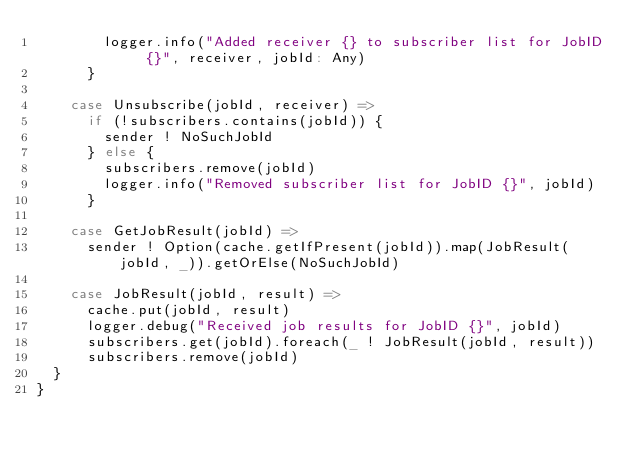Convert code to text. <code><loc_0><loc_0><loc_500><loc_500><_Scala_>        logger.info("Added receiver {} to subscriber list for JobID {}", receiver, jobId: Any)
      }

    case Unsubscribe(jobId, receiver) =>
      if (!subscribers.contains(jobId)) {
        sender ! NoSuchJobId
      } else {
        subscribers.remove(jobId)
        logger.info("Removed subscriber list for JobID {}", jobId)
      }

    case GetJobResult(jobId) =>
      sender ! Option(cache.getIfPresent(jobId)).map(JobResult(jobId, _)).getOrElse(NoSuchJobId)

    case JobResult(jobId, result) =>
      cache.put(jobId, result)
      logger.debug("Received job results for JobID {}", jobId)
      subscribers.get(jobId).foreach(_ ! JobResult(jobId, result))
      subscribers.remove(jobId)
  }
}</code> 